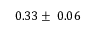<formula> <loc_0><loc_0><loc_500><loc_500>0 . 3 3 \pm \, 0 . 0 6</formula> 